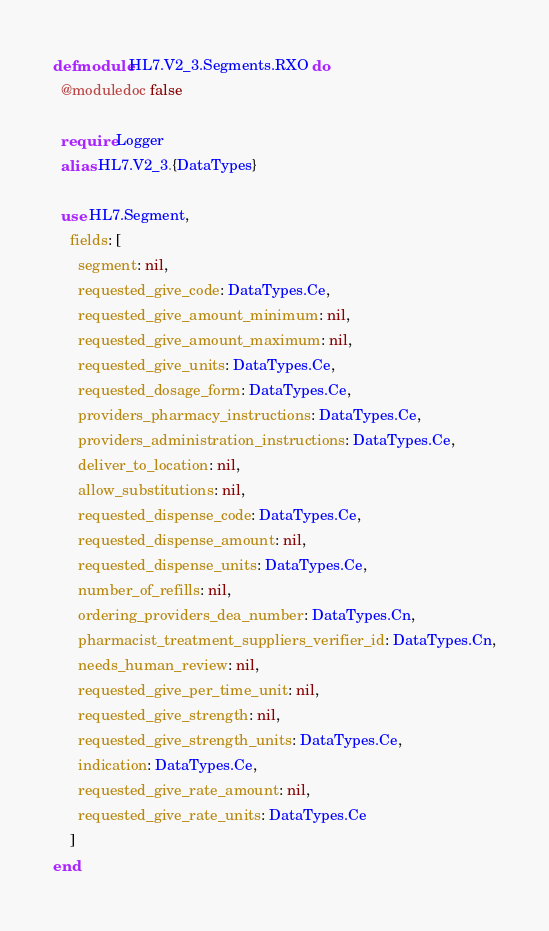<code> <loc_0><loc_0><loc_500><loc_500><_Elixir_>defmodule HL7.V2_3.Segments.RXO do
  @moduledoc false

  require Logger
  alias HL7.V2_3.{DataTypes}

  use HL7.Segment,
    fields: [
      segment: nil,
      requested_give_code: DataTypes.Ce,
      requested_give_amount_minimum: nil,
      requested_give_amount_maximum: nil,
      requested_give_units: DataTypes.Ce,
      requested_dosage_form: DataTypes.Ce,
      providers_pharmacy_instructions: DataTypes.Ce,
      providers_administration_instructions: DataTypes.Ce,
      deliver_to_location: nil,
      allow_substitutions: nil,
      requested_dispense_code: DataTypes.Ce,
      requested_dispense_amount: nil,
      requested_dispense_units: DataTypes.Ce,
      number_of_refills: nil,
      ordering_providers_dea_number: DataTypes.Cn,
      pharmacist_treatment_suppliers_verifier_id: DataTypes.Cn,
      needs_human_review: nil,
      requested_give_per_time_unit: nil,
      requested_give_strength: nil,
      requested_give_strength_units: DataTypes.Ce,
      indication: DataTypes.Ce,
      requested_give_rate_amount: nil,
      requested_give_rate_units: DataTypes.Ce
    ]
end
</code> 